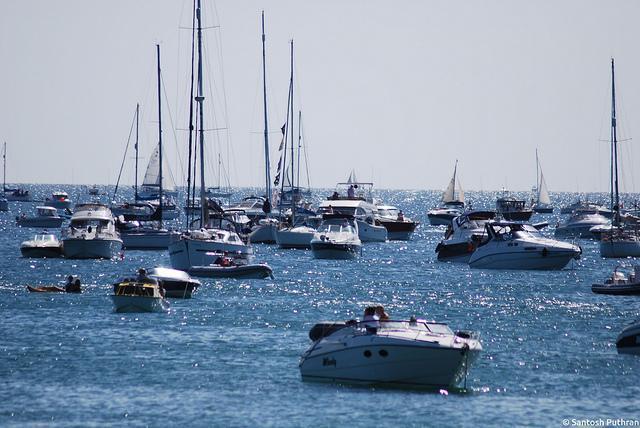How many boats can you see?
Give a very brief answer. 6. 